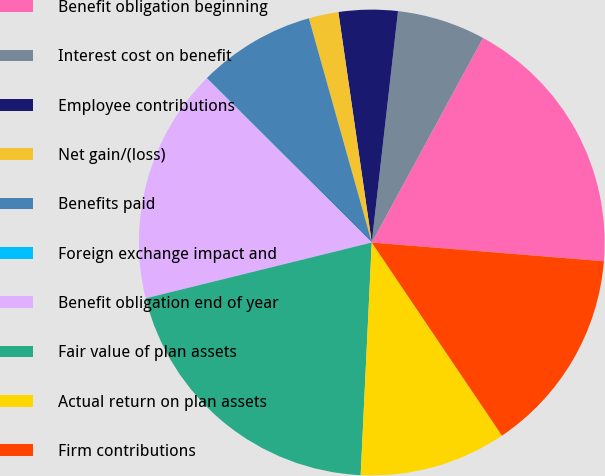Convert chart to OTSL. <chart><loc_0><loc_0><loc_500><loc_500><pie_chart><fcel>Benefit obligation beginning<fcel>Interest cost on benefit<fcel>Employee contributions<fcel>Net gain/(loss)<fcel>Benefits paid<fcel>Foreign exchange impact and<fcel>Benefit obligation end of year<fcel>Fair value of plan assets<fcel>Actual return on plan assets<fcel>Firm contributions<nl><fcel>18.35%<fcel>6.13%<fcel>4.09%<fcel>2.06%<fcel>8.17%<fcel>0.02%<fcel>16.31%<fcel>20.39%<fcel>10.2%<fcel>14.28%<nl></chart> 